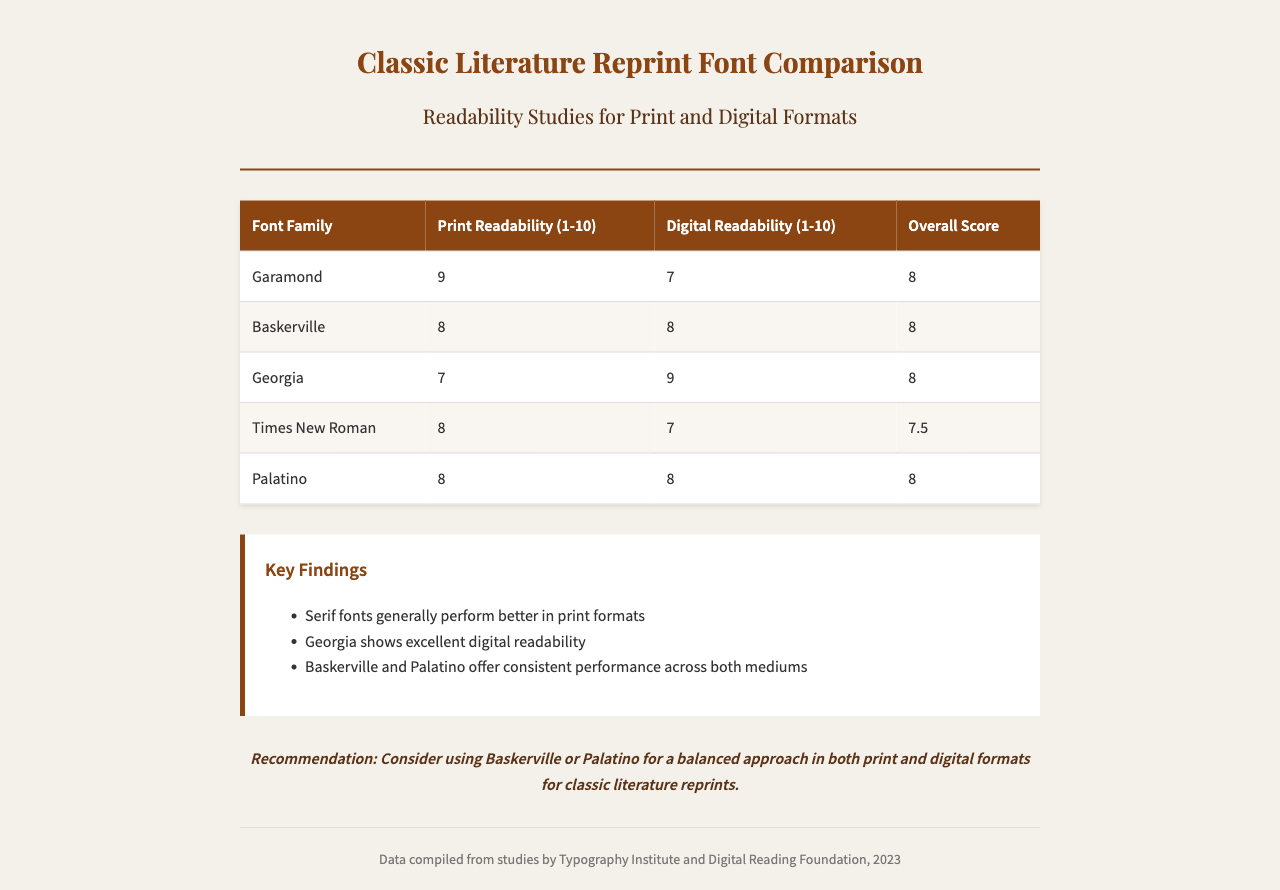What is the overall score for Garamond? The overall score for Garamond is listed in the table under "Overall Score", which is 8.
Answer: 8 Which font family has the highest digital readability? The font with the highest digital readability is Georgia, as indicated in the table with a score of 9.
Answer: Georgia What are the key findings related to serif fonts? The document states that serif fonts generally perform better in print formats, highlighting the performance trends for serif fonts.
Answer: Better in print How many font families are compared in the chart? The table lists a total of five font families, which are Garamond, Baskerville, Georgia, Times New Roman, and Palatino.
Answer: Five What is the recommendation provided in the document? The recommendation suggests using Baskerville or Palatino for a balanced approach in both print and digital formats.
Answer: Baskerville or Palatino What is the print readability score for Times New Roman? The print readability score for Times New Roman is given in the table, which shows a score of 8.
Answer: 8 Which organization compiled the data in the document? The data has been compiled by the Typography Institute and Digital Reading Foundation, as mentioned in the footer.
Answer: Typography Institute and Digital Reading Foundation What is the digital readability score for Palatino? The digital readability score for Palatino is included in the table and is listed as 8.
Answer: 8 